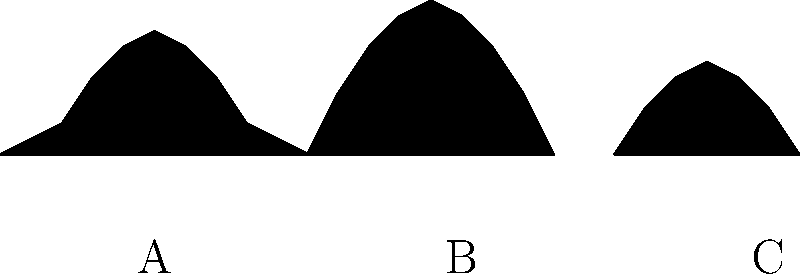Identify the Studio Ghibli character represented by silhouette B in the image above. To identify the Studio Ghibli character represented by silhouette B, let's analyze the shapes and characteristics of each silhouette:

1. Silhouette A: This shape has a large, round body with pointed ears on top. It resembles Totoro from "My Neighbor Totoro."

2. Silhouette B: This shape has an elongated, oval form with a slightly narrower bottom. The top of the silhouette is rounded, and there are no distinct features like ears or limbs. This shape is characteristic of No-Face (Kaonashi) from "Spirited Away."

3. Silhouette C: This shape is smaller and has a flame-like appearance with a wider base and a tapered top. It likely represents Calcifer, the fire demon from "Howl's Moving Castle."

Given the question asks specifically about silhouette B, we can conclude that this silhouette represents No-Face (Kaonashi) from "Spirited Away." No-Face is known for its distinctive mask-like face and amorphous body, which matches the featureless, oval shape of silhouette B.
Answer: No-Face (Kaonashi) 